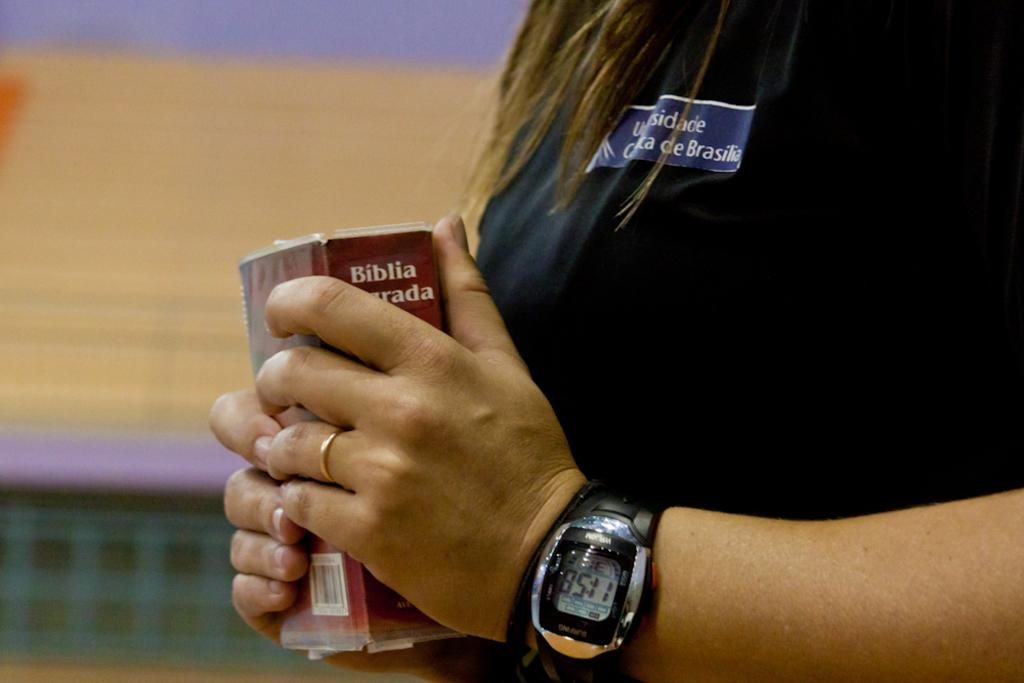<image>
Share a concise interpretation of the image provided. A bible is being held by a woman wearing a watch. 